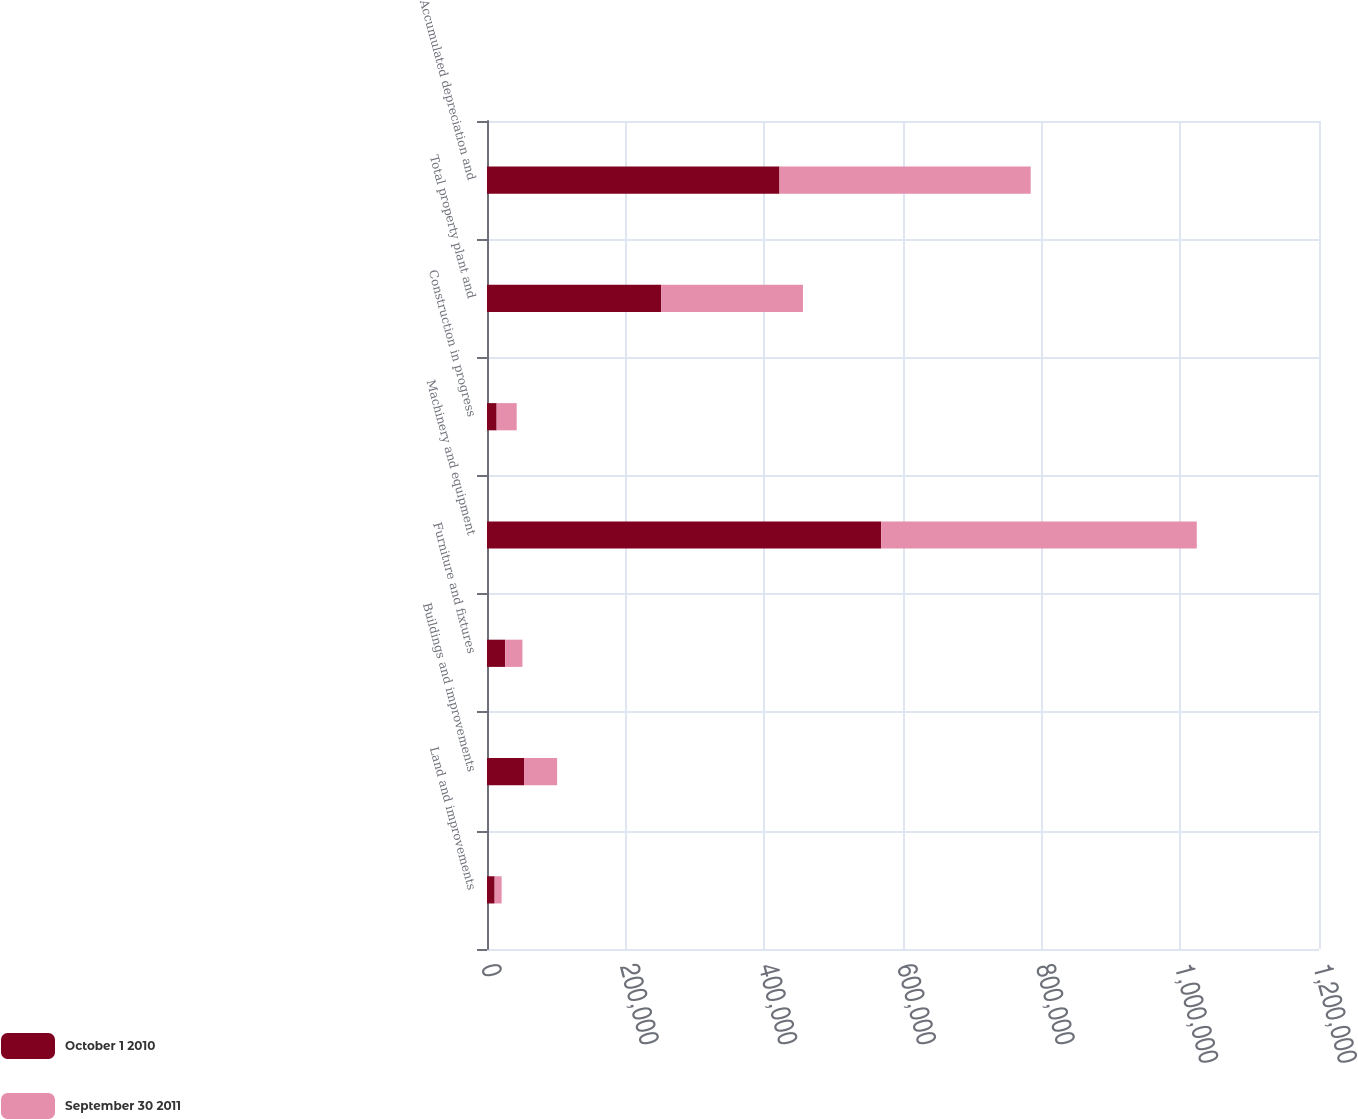Convert chart. <chart><loc_0><loc_0><loc_500><loc_500><stacked_bar_chart><ecel><fcel>Land and improvements<fcel>Buildings and improvements<fcel>Furniture and fixtures<fcel>Machinery and equipment<fcel>Construction in progress<fcel>Total property plant and<fcel>Accumulated depreciation and<nl><fcel>October 1 2010<fcel>11024<fcel>53397<fcel>26325<fcel>568563<fcel>13929<fcel>251365<fcel>421873<nl><fcel>September 30 2011<fcel>10082<fcel>47734<fcel>24784<fcel>455157<fcel>28901<fcel>204363<fcel>362295<nl></chart> 